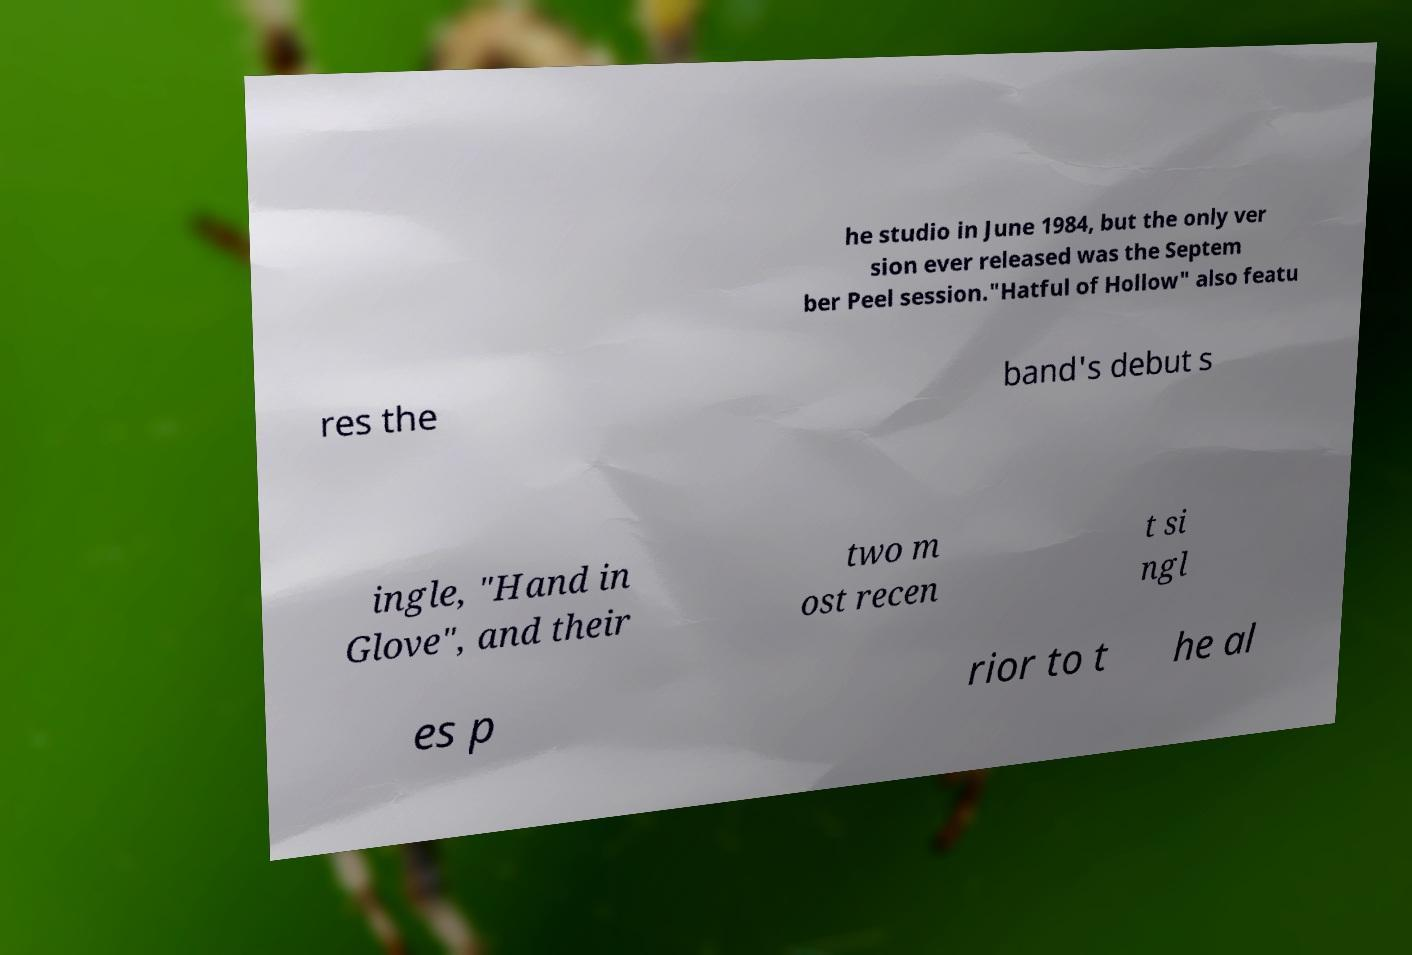For documentation purposes, I need the text within this image transcribed. Could you provide that? he studio in June 1984, but the only ver sion ever released was the Septem ber Peel session."Hatful of Hollow" also featu res the band's debut s ingle, "Hand in Glove", and their two m ost recen t si ngl es p rior to t he al 